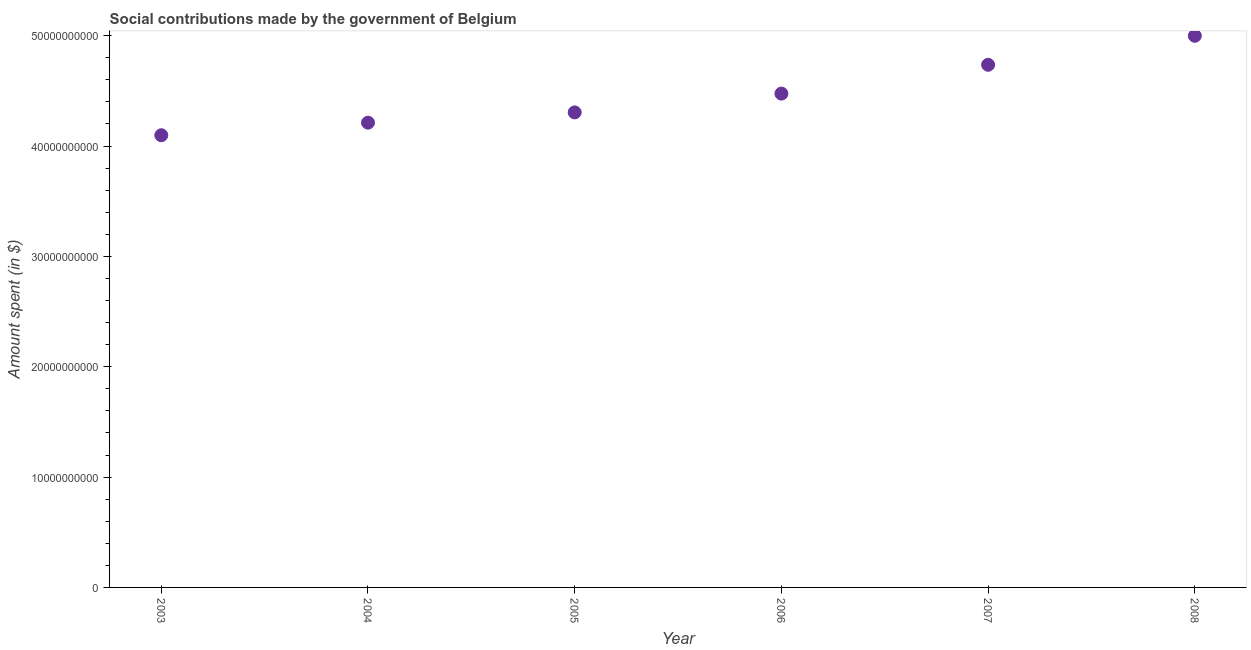What is the amount spent in making social contributions in 2008?
Provide a succinct answer. 5.00e+1. Across all years, what is the maximum amount spent in making social contributions?
Your response must be concise. 5.00e+1. Across all years, what is the minimum amount spent in making social contributions?
Offer a very short reply. 4.10e+1. In which year was the amount spent in making social contributions maximum?
Provide a short and direct response. 2008. What is the sum of the amount spent in making social contributions?
Your answer should be compact. 2.68e+11. What is the difference between the amount spent in making social contributions in 2004 and 2005?
Provide a succinct answer. -9.31e+08. What is the average amount spent in making social contributions per year?
Your response must be concise. 4.47e+1. What is the median amount spent in making social contributions?
Ensure brevity in your answer.  4.39e+1. What is the ratio of the amount spent in making social contributions in 2003 to that in 2008?
Your response must be concise. 0.82. Is the amount spent in making social contributions in 2004 less than that in 2005?
Keep it short and to the point. Yes. Is the difference between the amount spent in making social contributions in 2003 and 2005 greater than the difference between any two years?
Keep it short and to the point. No. What is the difference between the highest and the second highest amount spent in making social contributions?
Provide a short and direct response. 2.63e+09. Is the sum of the amount spent in making social contributions in 2003 and 2008 greater than the maximum amount spent in making social contributions across all years?
Your answer should be compact. Yes. What is the difference between the highest and the lowest amount spent in making social contributions?
Your response must be concise. 9.01e+09. In how many years, is the amount spent in making social contributions greater than the average amount spent in making social contributions taken over all years?
Give a very brief answer. 3. Does the amount spent in making social contributions monotonically increase over the years?
Offer a very short reply. Yes. How many dotlines are there?
Give a very brief answer. 1. What is the difference between two consecutive major ticks on the Y-axis?
Make the answer very short. 1.00e+1. Are the values on the major ticks of Y-axis written in scientific E-notation?
Provide a succinct answer. No. Does the graph contain any zero values?
Provide a short and direct response. No. Does the graph contain grids?
Provide a succinct answer. No. What is the title of the graph?
Your answer should be very brief. Social contributions made by the government of Belgium. What is the label or title of the X-axis?
Give a very brief answer. Year. What is the label or title of the Y-axis?
Your answer should be very brief. Amount spent (in $). What is the Amount spent (in $) in 2003?
Your answer should be compact. 4.10e+1. What is the Amount spent (in $) in 2004?
Keep it short and to the point. 4.21e+1. What is the Amount spent (in $) in 2005?
Provide a succinct answer. 4.30e+1. What is the Amount spent (in $) in 2006?
Your answer should be compact. 4.48e+1. What is the Amount spent (in $) in 2007?
Keep it short and to the point. 4.74e+1. What is the Amount spent (in $) in 2008?
Ensure brevity in your answer.  5.00e+1. What is the difference between the Amount spent (in $) in 2003 and 2004?
Provide a succinct answer. -1.14e+09. What is the difference between the Amount spent (in $) in 2003 and 2005?
Give a very brief answer. -2.07e+09. What is the difference between the Amount spent (in $) in 2003 and 2006?
Give a very brief answer. -3.77e+09. What is the difference between the Amount spent (in $) in 2003 and 2007?
Keep it short and to the point. -6.39e+09. What is the difference between the Amount spent (in $) in 2003 and 2008?
Your response must be concise. -9.01e+09. What is the difference between the Amount spent (in $) in 2004 and 2005?
Offer a terse response. -9.31e+08. What is the difference between the Amount spent (in $) in 2004 and 2006?
Make the answer very short. -2.63e+09. What is the difference between the Amount spent (in $) in 2004 and 2007?
Your answer should be very brief. -5.25e+09. What is the difference between the Amount spent (in $) in 2004 and 2008?
Provide a short and direct response. -7.87e+09. What is the difference between the Amount spent (in $) in 2005 and 2006?
Offer a terse response. -1.70e+09. What is the difference between the Amount spent (in $) in 2005 and 2007?
Ensure brevity in your answer.  -4.31e+09. What is the difference between the Amount spent (in $) in 2005 and 2008?
Ensure brevity in your answer.  -6.94e+09. What is the difference between the Amount spent (in $) in 2006 and 2007?
Your answer should be very brief. -2.61e+09. What is the difference between the Amount spent (in $) in 2006 and 2008?
Make the answer very short. -5.24e+09. What is the difference between the Amount spent (in $) in 2007 and 2008?
Offer a very short reply. -2.63e+09. What is the ratio of the Amount spent (in $) in 2003 to that in 2005?
Make the answer very short. 0.95. What is the ratio of the Amount spent (in $) in 2003 to that in 2006?
Offer a terse response. 0.92. What is the ratio of the Amount spent (in $) in 2003 to that in 2007?
Your response must be concise. 0.86. What is the ratio of the Amount spent (in $) in 2003 to that in 2008?
Offer a very short reply. 0.82. What is the ratio of the Amount spent (in $) in 2004 to that in 2006?
Your answer should be very brief. 0.94. What is the ratio of the Amount spent (in $) in 2004 to that in 2007?
Your answer should be very brief. 0.89. What is the ratio of the Amount spent (in $) in 2004 to that in 2008?
Offer a terse response. 0.84. What is the ratio of the Amount spent (in $) in 2005 to that in 2006?
Make the answer very short. 0.96. What is the ratio of the Amount spent (in $) in 2005 to that in 2007?
Ensure brevity in your answer.  0.91. What is the ratio of the Amount spent (in $) in 2005 to that in 2008?
Ensure brevity in your answer.  0.86. What is the ratio of the Amount spent (in $) in 2006 to that in 2007?
Your response must be concise. 0.94. What is the ratio of the Amount spent (in $) in 2006 to that in 2008?
Your response must be concise. 0.9. What is the ratio of the Amount spent (in $) in 2007 to that in 2008?
Offer a very short reply. 0.95. 